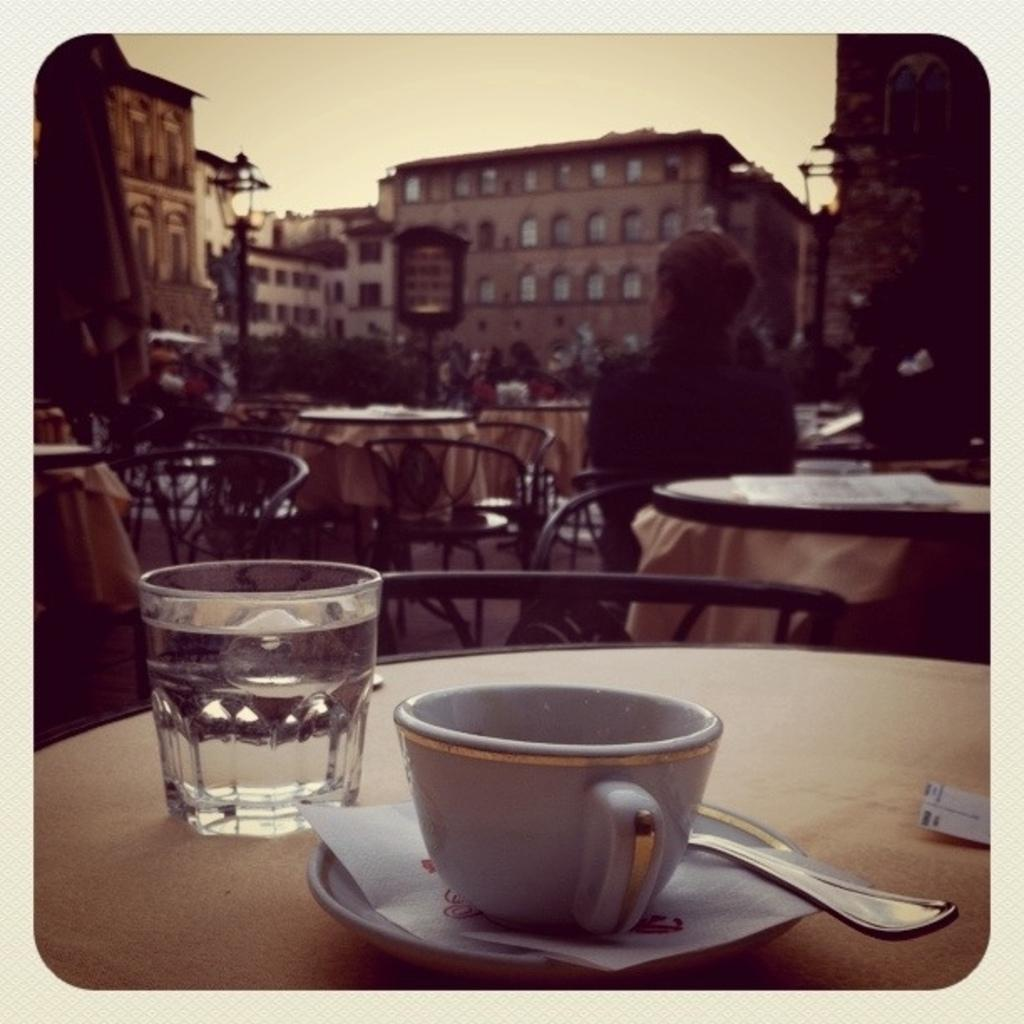What is placed on the table in the image? There is a coffee cup and a water glass on the table in the image. What is the woman doing in the image? The woman is sitting on another table. What can be seen in the background of the image? There is a building visible on the opposite road. What type of grain is being used as bait for the tail in the image? There is no grain, bait, or tail present in the image. 